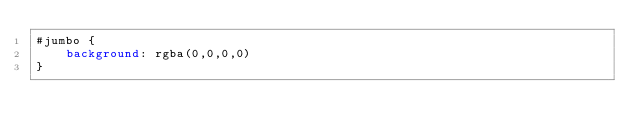Convert code to text. <code><loc_0><loc_0><loc_500><loc_500><_CSS_>#jumbo {
    background: rgba(0,0,0,0)
}</code> 